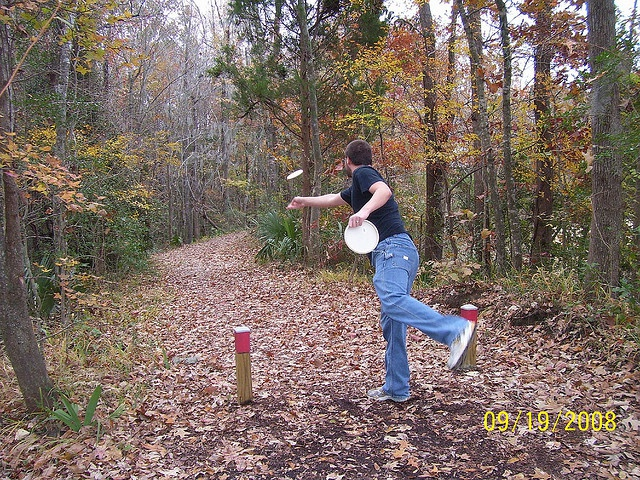Describe the objects in this image and their specific colors. I can see people in gray, black, and lavender tones, frisbee in gray, white, darkgray, and black tones, and frisbee in gray, white, darkgray, and black tones in this image. 